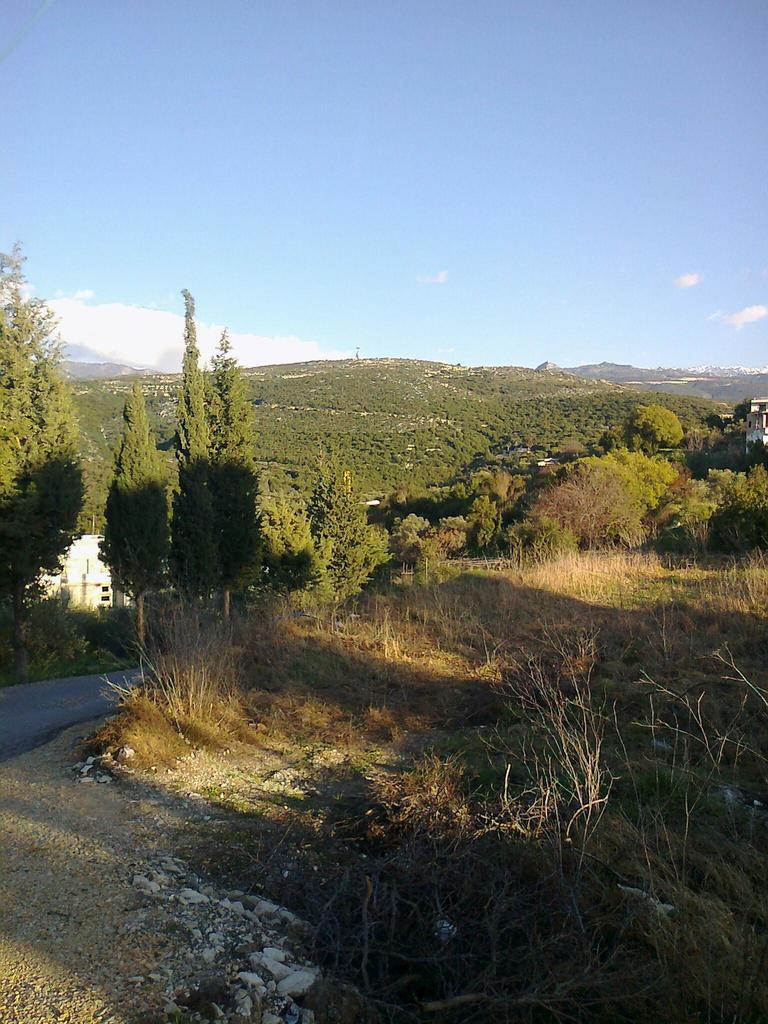What type of terrain is depicted in the image? There is a grassy land in the image. What can be found at the bottom of the image? Stones are present at the bottom of the image. What other natural elements are visible in the image? There are trees in the middle of the image. What is visible in the background of the image? The sky is visible in the background of the image. What color is the sweater worn by the rock in the image? There is no rock or sweater present in the image. 